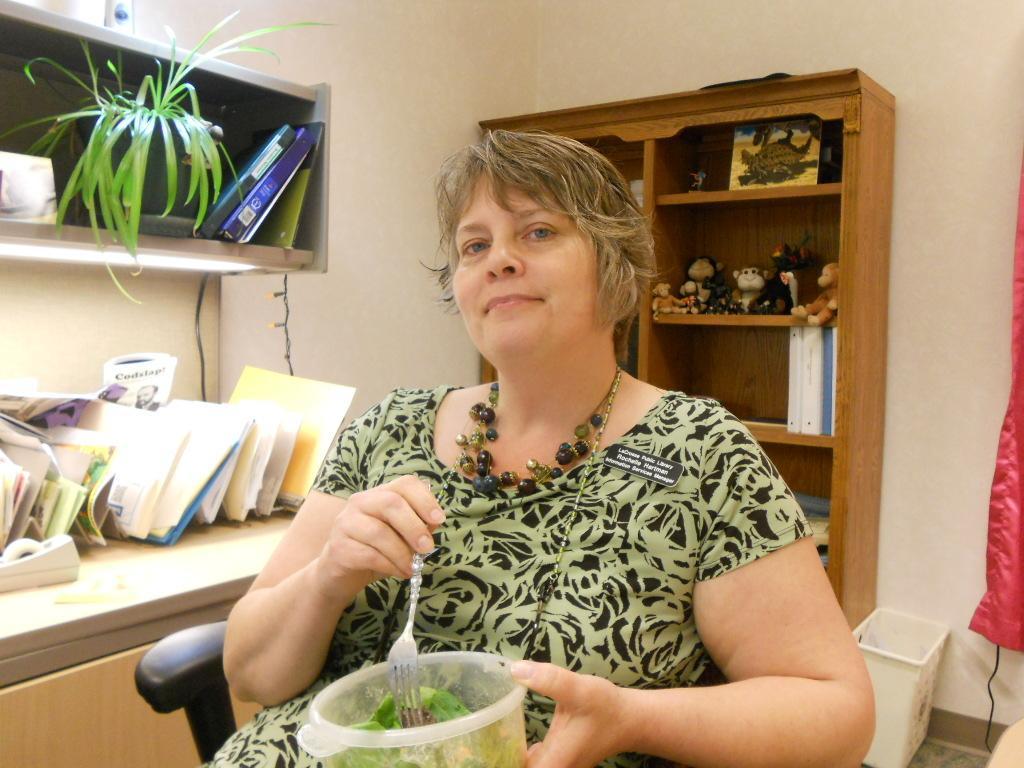Describe this image in one or two sentences. In the image there is a woman she is holding a box containing some food and she is holding a fork with another hand, behind the woman there is a cupboard and there are some objects kept in the shelf of the cupboard, on the left side there is a table and on the table there are books and files, in the background there is a wall. 